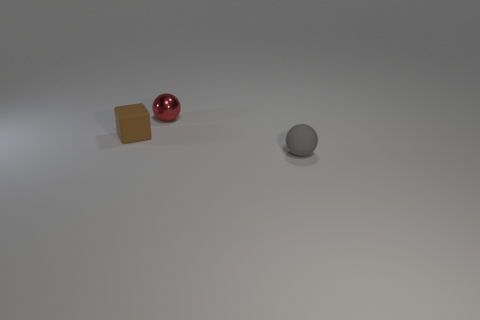Is there any other thing that is made of the same material as the tiny red object?
Offer a very short reply. No. What is the material of the ball that is in front of the tiny matte thing left of the tiny matte sphere in front of the small brown thing?
Provide a short and direct response. Rubber. Do the gray matte object and the red object have the same shape?
Offer a very short reply. Yes. There is a red object that is the same shape as the gray thing; what is it made of?
Your response must be concise. Metal. There is another object that is made of the same material as the brown thing; what is its size?
Offer a very short reply. Small. How many brown objects are either rubber objects or small matte spheres?
Give a very brief answer. 1. There is a sphere on the left side of the small matte ball; how many brown rubber things are behind it?
Provide a short and direct response. 0. Are there more small brown things in front of the metallic object than tiny red objects to the right of the small gray matte object?
Your answer should be very brief. Yes. What is the small cube made of?
Your answer should be compact. Rubber. Are there any gray matte balls that have the same size as the brown rubber cube?
Keep it short and to the point. Yes. 